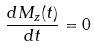Convert formula to latex. <formula><loc_0><loc_0><loc_500><loc_500>\frac { d M _ { z } ( t ) } { d t } = 0</formula> 